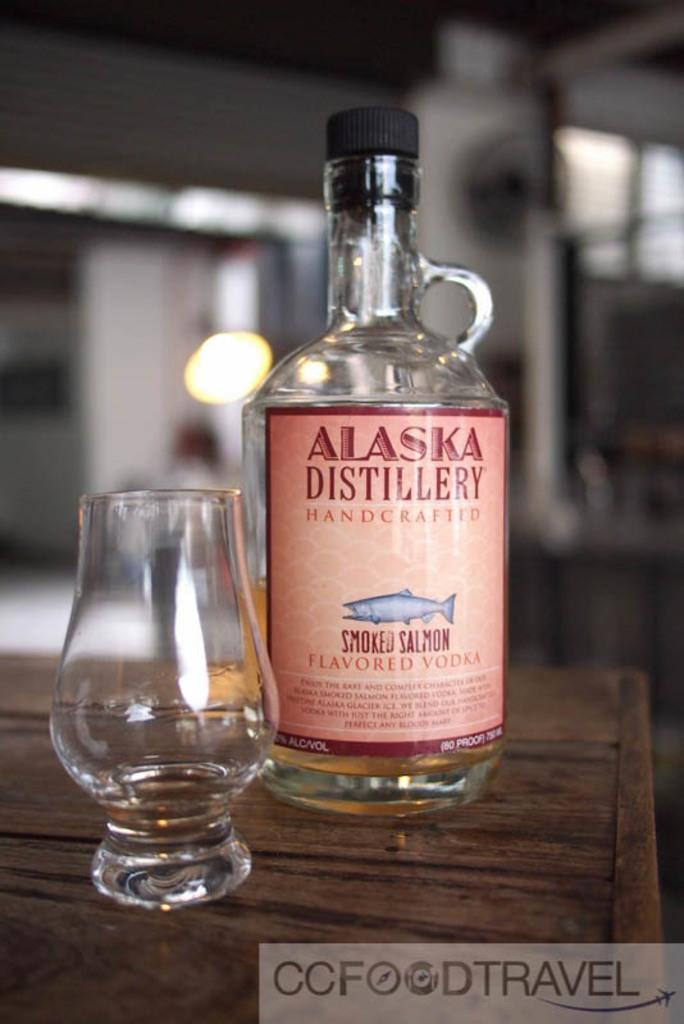Provide a one-sentence caption for the provided image. A bottle of Alaska Distillery Handcrafted Smoked Salmon Flavored Vodka sits on a table next to a glass. 